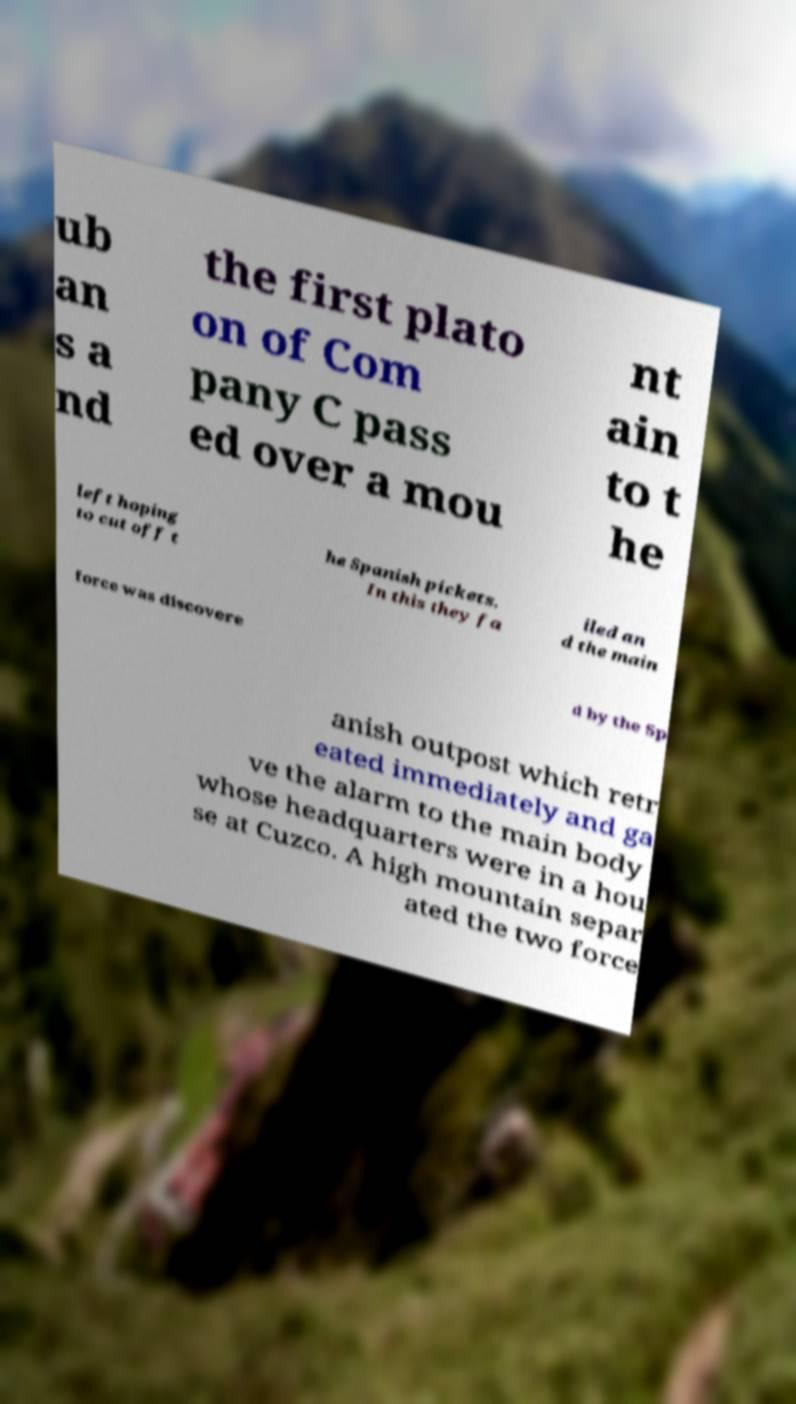Can you accurately transcribe the text from the provided image for me? ub an s a nd the first plato on of Com pany C pass ed over a mou nt ain to t he left hoping to cut off t he Spanish pickets. In this they fa iled an d the main force was discovere d by the Sp anish outpost which retr eated immediately and ga ve the alarm to the main body whose headquarters were in a hou se at Cuzco. A high mountain separ ated the two force 